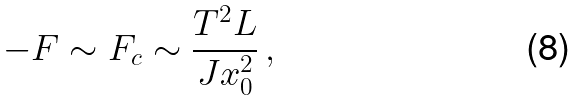Convert formula to latex. <formula><loc_0><loc_0><loc_500><loc_500>- F \sim F _ { c } \sim \frac { T ^ { 2 } L } { J x _ { 0 } ^ { 2 } } \, ,</formula> 